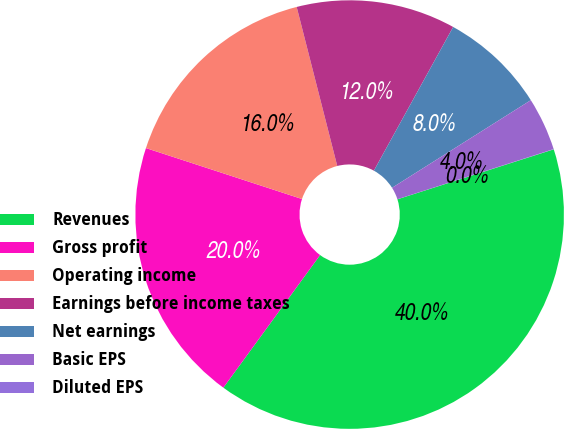<chart> <loc_0><loc_0><loc_500><loc_500><pie_chart><fcel>Revenues<fcel>Gross profit<fcel>Operating income<fcel>Earnings before income taxes<fcel>Net earnings<fcel>Basic EPS<fcel>Diluted EPS<nl><fcel>39.95%<fcel>19.99%<fcel>16.0%<fcel>12.0%<fcel>8.01%<fcel>4.02%<fcel>0.02%<nl></chart> 